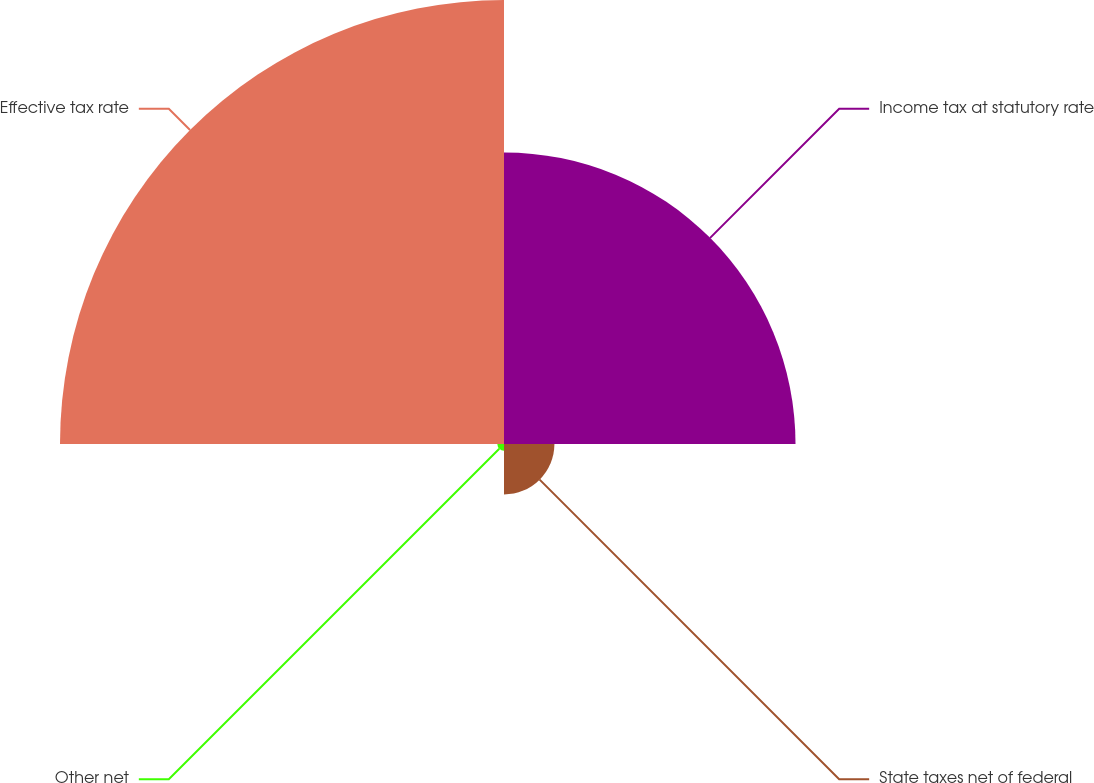Convert chart to OTSL. <chart><loc_0><loc_0><loc_500><loc_500><pie_chart><fcel>Income tax at statutory rate<fcel>State taxes net of federal<fcel>Other net<fcel>Effective tax rate<nl><fcel>36.78%<fcel>6.36%<fcel>0.84%<fcel>56.02%<nl></chart> 